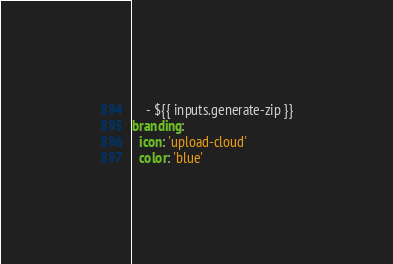<code> <loc_0><loc_0><loc_500><loc_500><_YAML_>    - ${{ inputs.generate-zip }}
branding:
  icon: 'upload-cloud'
  color: 'blue'
</code> 